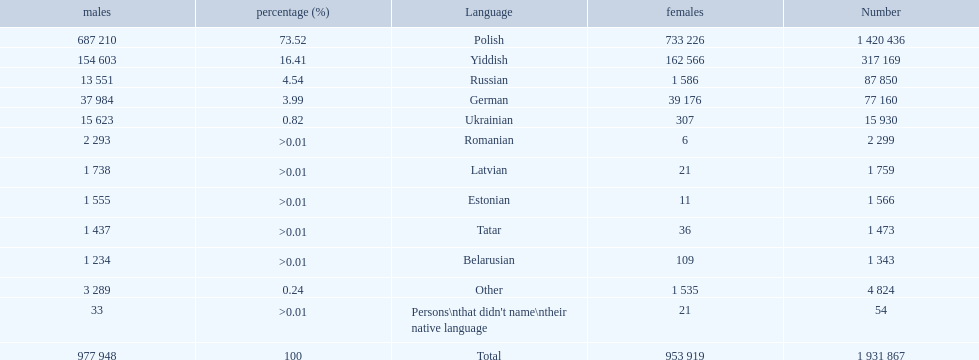Which languages had percentages of >0.01? Romanian, Latvian, Estonian, Tatar, Belarusian. What was the top language? Romanian. 